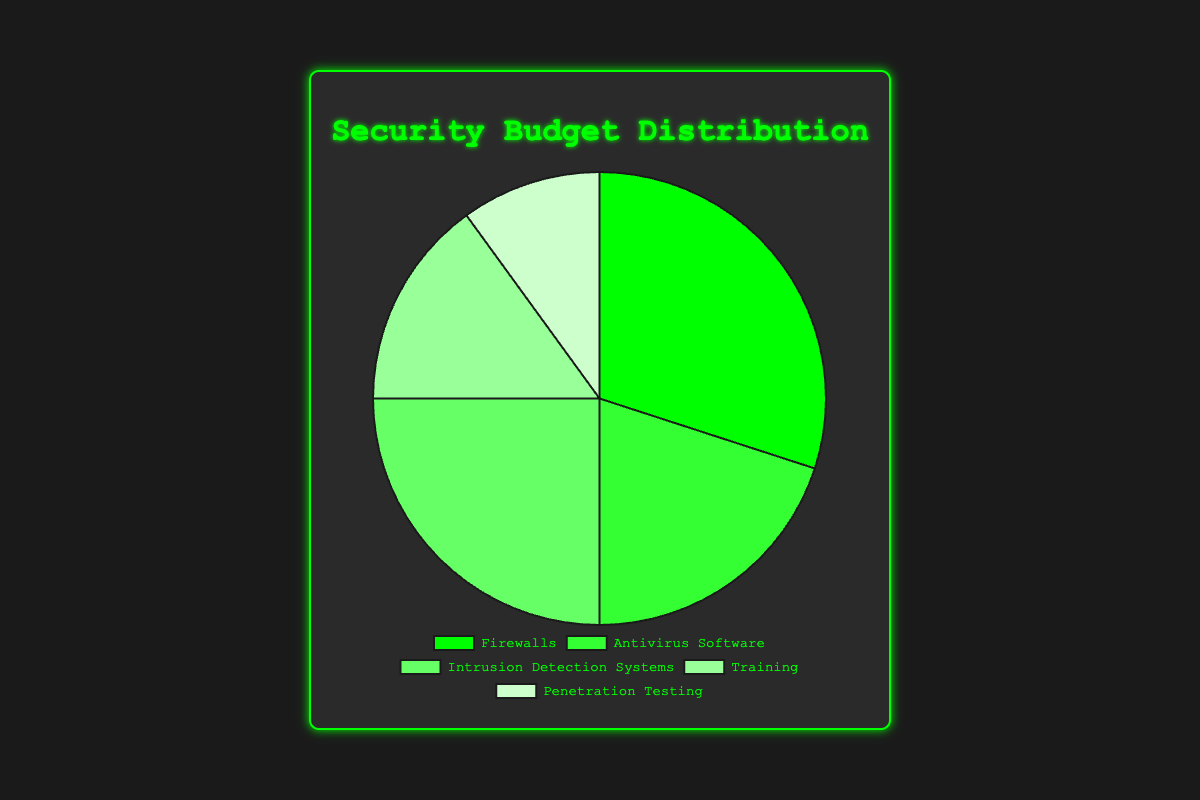What is the largest allocation in the security budget and what percentage is it? By observing the pie chart, the largest slice corresponds to Firewalls, which is visually the largest area in the chart and is labeled as 30%.
Answer: Firewalls, 30% Compare the budget allocation for Firewalls and Antivirus Software. Which one has a higher percentage and by how much? Firewalls have a 30% allocation, while Antivirus Software has 20%. The difference between them is 30% - 20% = 10%.
Answer: Firewalls, by 10% What is the total percentage of the budget allocated to Intrusion Detection Systems and Penetration Testing combined? Intrusion Detection Systems have an allocation of 25% and Penetration Testing has 10%. The total combined is 25% + 10% = 35%.
Answer: 35% Which budget category has the smallest allocation and what is its percentage? By looking at the chart, the smallest slice corresponds to Penetration Testing with a label indicating 10%.
Answer: Penetration Testing, 10% How much more percentage is allocated to Training compared to Penetration Testing? Training has a 15% allocation, while Penetration Testing has 10%. The difference between them is 15% - 10% = 5%.
Answer: 5% If you were to equally split the budget allocated to Firewalls and Antivirus Software between them, what would be the new percentages for each? The sum of Firewalls (30%) and Antivirus Software (20%) is 50%. If split equally, each would get 50% / 2 = 25%.
Answer: 25% each By what percentage does the budget allocated to Intrusion Detection Systems differ from the budget allocated to Training? Intrusion Detection Systems have a 25% allocation, and Training has 15%. The difference is 25% - 15% = 10%.
Answer: 10% What is the average percentage of the listed budget categories? There are five categories: Firewalls (30%), Antivirus Software (20%), Intrusion Detection Systems (25%), Training (15%), and Penetration Testing (10%). The average is (30% + 20% + 25% + 15% + 10%) / 5 = 20%.
Answer: 20% Which sector has a middle allocation among the listed categories once sorted in ascending order of percentage allocation? The sorted order is Penetration Testing (10%), Training (15%), Antivirus Software (20%), Intrusion Detection Systems (25%), Firewalls (30%). The middle value is Antivirus Software with 20%.
Answer: Antivirus Software, 20% What proportion of the total security budget is not allocated to Training and Penetration Testing? Training is 15% and Penetration Testing is 10%, totaling 25%. The remaining budget is 100% - 25% = 75%.
Answer: 75% 